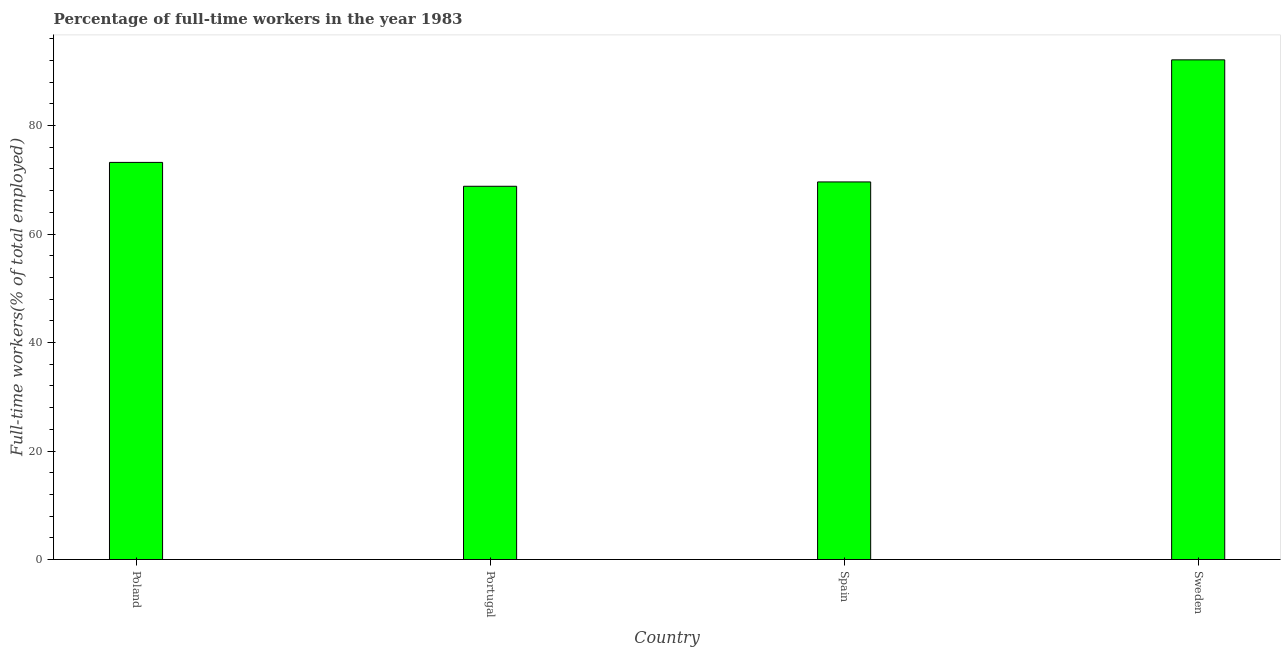What is the title of the graph?
Make the answer very short. Percentage of full-time workers in the year 1983. What is the label or title of the X-axis?
Offer a terse response. Country. What is the label or title of the Y-axis?
Your answer should be compact. Full-time workers(% of total employed). What is the percentage of full-time workers in Spain?
Give a very brief answer. 69.6. Across all countries, what is the maximum percentage of full-time workers?
Give a very brief answer. 92.1. Across all countries, what is the minimum percentage of full-time workers?
Ensure brevity in your answer.  68.8. In which country was the percentage of full-time workers maximum?
Keep it short and to the point. Sweden. What is the sum of the percentage of full-time workers?
Keep it short and to the point. 303.7. What is the average percentage of full-time workers per country?
Ensure brevity in your answer.  75.92. What is the median percentage of full-time workers?
Offer a very short reply. 71.4. In how many countries, is the percentage of full-time workers greater than 56 %?
Provide a short and direct response. 4. What is the ratio of the percentage of full-time workers in Portugal to that in Sweden?
Ensure brevity in your answer.  0.75. What is the difference between the highest and the second highest percentage of full-time workers?
Your answer should be very brief. 18.9. Is the sum of the percentage of full-time workers in Portugal and Sweden greater than the maximum percentage of full-time workers across all countries?
Provide a short and direct response. Yes. What is the difference between the highest and the lowest percentage of full-time workers?
Provide a succinct answer. 23.3. In how many countries, is the percentage of full-time workers greater than the average percentage of full-time workers taken over all countries?
Keep it short and to the point. 1. How many bars are there?
Keep it short and to the point. 4. Are all the bars in the graph horizontal?
Offer a terse response. No. How many countries are there in the graph?
Make the answer very short. 4. What is the difference between two consecutive major ticks on the Y-axis?
Ensure brevity in your answer.  20. Are the values on the major ticks of Y-axis written in scientific E-notation?
Offer a terse response. No. What is the Full-time workers(% of total employed) in Poland?
Make the answer very short. 73.2. What is the Full-time workers(% of total employed) in Portugal?
Your answer should be compact. 68.8. What is the Full-time workers(% of total employed) of Spain?
Your answer should be very brief. 69.6. What is the Full-time workers(% of total employed) in Sweden?
Provide a short and direct response. 92.1. What is the difference between the Full-time workers(% of total employed) in Poland and Portugal?
Provide a short and direct response. 4.4. What is the difference between the Full-time workers(% of total employed) in Poland and Sweden?
Provide a succinct answer. -18.9. What is the difference between the Full-time workers(% of total employed) in Portugal and Spain?
Offer a very short reply. -0.8. What is the difference between the Full-time workers(% of total employed) in Portugal and Sweden?
Your answer should be very brief. -23.3. What is the difference between the Full-time workers(% of total employed) in Spain and Sweden?
Keep it short and to the point. -22.5. What is the ratio of the Full-time workers(% of total employed) in Poland to that in Portugal?
Keep it short and to the point. 1.06. What is the ratio of the Full-time workers(% of total employed) in Poland to that in Spain?
Your answer should be compact. 1.05. What is the ratio of the Full-time workers(% of total employed) in Poland to that in Sweden?
Make the answer very short. 0.8. What is the ratio of the Full-time workers(% of total employed) in Portugal to that in Sweden?
Offer a very short reply. 0.75. What is the ratio of the Full-time workers(% of total employed) in Spain to that in Sweden?
Ensure brevity in your answer.  0.76. 